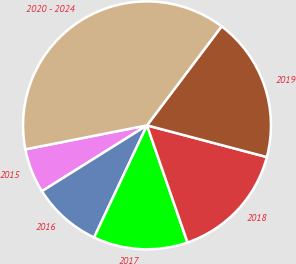Convert chart. <chart><loc_0><loc_0><loc_500><loc_500><pie_chart><fcel>2015<fcel>2016<fcel>2017<fcel>2018<fcel>2019<fcel>2020 - 2024<nl><fcel>5.81%<fcel>9.07%<fcel>12.32%<fcel>15.58%<fcel>18.84%<fcel>38.38%<nl></chart> 